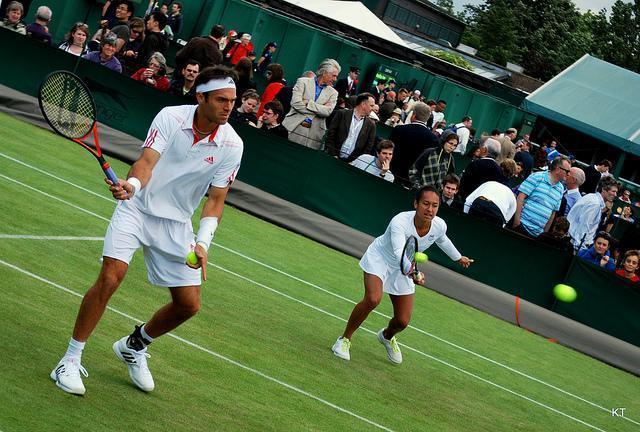How many tennis balls do you see?
Give a very brief answer. 3. How many people are in the photo?
Give a very brief answer. 6. 